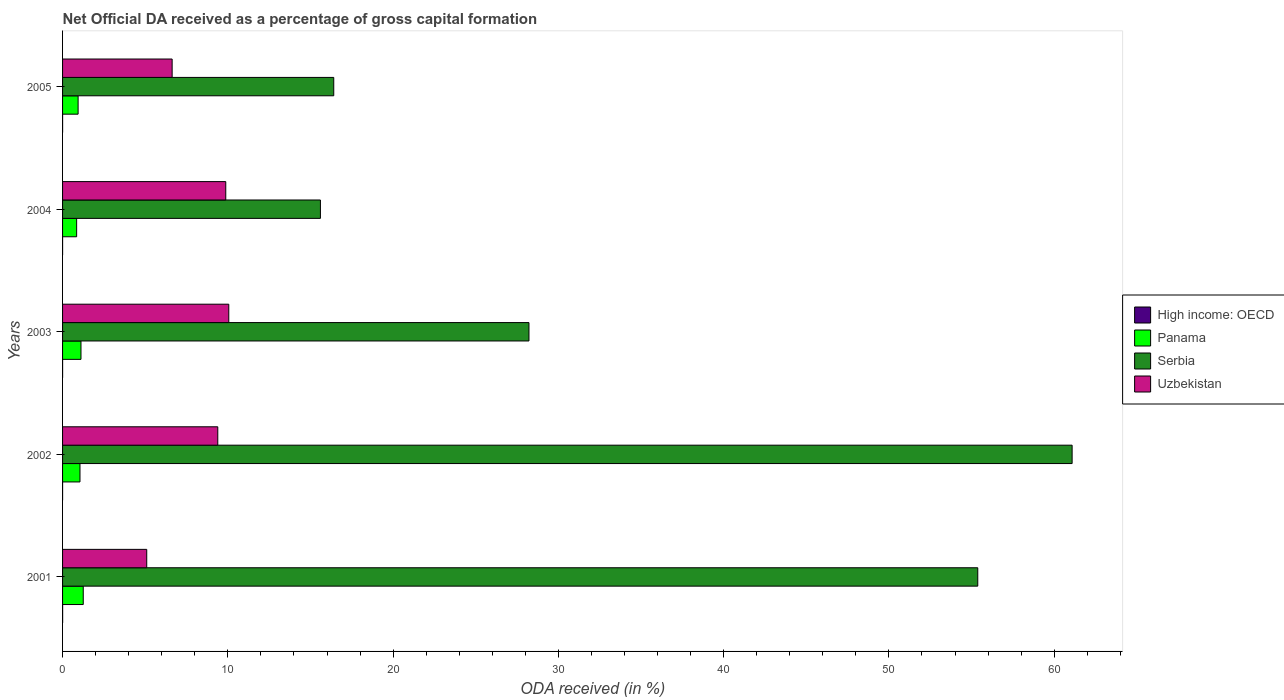How many different coloured bars are there?
Ensure brevity in your answer.  4. How many bars are there on the 2nd tick from the bottom?
Keep it short and to the point. 4. What is the net ODA received in Uzbekistan in 2001?
Provide a short and direct response. 5.09. Across all years, what is the maximum net ODA received in Serbia?
Provide a short and direct response. 61.08. Across all years, what is the minimum net ODA received in Uzbekistan?
Provide a succinct answer. 5.09. In which year was the net ODA received in Panama maximum?
Offer a terse response. 2001. What is the total net ODA received in Serbia in the graph?
Ensure brevity in your answer.  176.69. What is the difference between the net ODA received in Uzbekistan in 2004 and that in 2005?
Give a very brief answer. 3.24. What is the difference between the net ODA received in Serbia in 2001 and the net ODA received in Uzbekistan in 2002?
Provide a succinct answer. 45.98. What is the average net ODA received in High income: OECD per year?
Your response must be concise. 0. In the year 2001, what is the difference between the net ODA received in Uzbekistan and net ODA received in Panama?
Your answer should be very brief. 3.84. What is the ratio of the net ODA received in Uzbekistan in 2003 to that in 2005?
Keep it short and to the point. 1.52. Is the difference between the net ODA received in Uzbekistan in 2002 and 2003 greater than the difference between the net ODA received in Panama in 2002 and 2003?
Your answer should be very brief. No. What is the difference between the highest and the second highest net ODA received in Serbia?
Make the answer very short. 5.71. What is the difference between the highest and the lowest net ODA received in High income: OECD?
Offer a terse response. 0. What does the 4th bar from the top in 2001 represents?
Your answer should be compact. High income: OECD. What does the 1st bar from the bottom in 2001 represents?
Provide a succinct answer. High income: OECD. Are all the bars in the graph horizontal?
Your answer should be compact. Yes. Are the values on the major ticks of X-axis written in scientific E-notation?
Give a very brief answer. No. Does the graph contain any zero values?
Keep it short and to the point. No. How many legend labels are there?
Ensure brevity in your answer.  4. What is the title of the graph?
Ensure brevity in your answer.  Net Official DA received as a percentage of gross capital formation. Does "Vietnam" appear as one of the legend labels in the graph?
Ensure brevity in your answer.  No. What is the label or title of the X-axis?
Offer a terse response. ODA received (in %). What is the label or title of the Y-axis?
Your answer should be very brief. Years. What is the ODA received (in %) of High income: OECD in 2001?
Provide a succinct answer. 0. What is the ODA received (in %) of Panama in 2001?
Ensure brevity in your answer.  1.25. What is the ODA received (in %) in Serbia in 2001?
Your answer should be very brief. 55.38. What is the ODA received (in %) in Uzbekistan in 2001?
Offer a very short reply. 5.09. What is the ODA received (in %) in High income: OECD in 2002?
Provide a succinct answer. 0. What is the ODA received (in %) of Panama in 2002?
Your response must be concise. 1.05. What is the ODA received (in %) in Serbia in 2002?
Provide a short and direct response. 61.08. What is the ODA received (in %) of Uzbekistan in 2002?
Your response must be concise. 9.39. What is the ODA received (in %) in High income: OECD in 2003?
Your answer should be compact. 0. What is the ODA received (in %) of Panama in 2003?
Your response must be concise. 1.11. What is the ODA received (in %) of Serbia in 2003?
Ensure brevity in your answer.  28.22. What is the ODA received (in %) in Uzbekistan in 2003?
Give a very brief answer. 10.06. What is the ODA received (in %) in High income: OECD in 2004?
Your response must be concise. 0. What is the ODA received (in %) in Panama in 2004?
Provide a succinct answer. 0.85. What is the ODA received (in %) in Serbia in 2004?
Offer a terse response. 15.6. What is the ODA received (in %) of Uzbekistan in 2004?
Provide a short and direct response. 9.87. What is the ODA received (in %) of High income: OECD in 2005?
Offer a terse response. 0. What is the ODA received (in %) of Panama in 2005?
Your answer should be very brief. 0.94. What is the ODA received (in %) in Serbia in 2005?
Make the answer very short. 16.41. What is the ODA received (in %) in Uzbekistan in 2005?
Your answer should be compact. 6.63. Across all years, what is the maximum ODA received (in %) in High income: OECD?
Give a very brief answer. 0. Across all years, what is the maximum ODA received (in %) of Panama?
Give a very brief answer. 1.25. Across all years, what is the maximum ODA received (in %) of Serbia?
Provide a succinct answer. 61.08. Across all years, what is the maximum ODA received (in %) in Uzbekistan?
Provide a succinct answer. 10.06. Across all years, what is the minimum ODA received (in %) of High income: OECD?
Give a very brief answer. 0. Across all years, what is the minimum ODA received (in %) of Panama?
Provide a succinct answer. 0.85. Across all years, what is the minimum ODA received (in %) of Serbia?
Your answer should be very brief. 15.6. Across all years, what is the minimum ODA received (in %) of Uzbekistan?
Provide a succinct answer. 5.09. What is the total ODA received (in %) of High income: OECD in the graph?
Offer a very short reply. 0.01. What is the total ODA received (in %) of Panama in the graph?
Make the answer very short. 5.21. What is the total ODA received (in %) in Serbia in the graph?
Keep it short and to the point. 176.69. What is the total ODA received (in %) of Uzbekistan in the graph?
Offer a very short reply. 41.05. What is the difference between the ODA received (in %) of High income: OECD in 2001 and that in 2002?
Offer a terse response. 0. What is the difference between the ODA received (in %) of Panama in 2001 and that in 2002?
Your answer should be very brief. 0.2. What is the difference between the ODA received (in %) in Serbia in 2001 and that in 2002?
Your answer should be compact. -5.71. What is the difference between the ODA received (in %) of Uzbekistan in 2001 and that in 2002?
Ensure brevity in your answer.  -4.3. What is the difference between the ODA received (in %) in High income: OECD in 2001 and that in 2003?
Provide a succinct answer. 0. What is the difference between the ODA received (in %) of Panama in 2001 and that in 2003?
Make the answer very short. 0.14. What is the difference between the ODA received (in %) in Serbia in 2001 and that in 2003?
Provide a short and direct response. 27.16. What is the difference between the ODA received (in %) of Uzbekistan in 2001 and that in 2003?
Offer a terse response. -4.96. What is the difference between the ODA received (in %) of High income: OECD in 2001 and that in 2004?
Offer a terse response. 0. What is the difference between the ODA received (in %) in Panama in 2001 and that in 2004?
Your answer should be very brief. 0.4. What is the difference between the ODA received (in %) of Serbia in 2001 and that in 2004?
Offer a terse response. 39.77. What is the difference between the ODA received (in %) in Uzbekistan in 2001 and that in 2004?
Offer a terse response. -4.78. What is the difference between the ODA received (in %) of High income: OECD in 2001 and that in 2005?
Ensure brevity in your answer.  0. What is the difference between the ODA received (in %) of Panama in 2001 and that in 2005?
Your answer should be compact. 0.31. What is the difference between the ODA received (in %) in Serbia in 2001 and that in 2005?
Provide a succinct answer. 38.97. What is the difference between the ODA received (in %) of Uzbekistan in 2001 and that in 2005?
Your answer should be compact. -1.54. What is the difference between the ODA received (in %) of High income: OECD in 2002 and that in 2003?
Offer a terse response. -0. What is the difference between the ODA received (in %) of Panama in 2002 and that in 2003?
Offer a terse response. -0.06. What is the difference between the ODA received (in %) of Serbia in 2002 and that in 2003?
Ensure brevity in your answer.  32.86. What is the difference between the ODA received (in %) in Uzbekistan in 2002 and that in 2003?
Offer a very short reply. -0.67. What is the difference between the ODA received (in %) in High income: OECD in 2002 and that in 2004?
Your answer should be very brief. 0. What is the difference between the ODA received (in %) of Panama in 2002 and that in 2004?
Offer a terse response. 0.2. What is the difference between the ODA received (in %) of Serbia in 2002 and that in 2004?
Make the answer very short. 45.48. What is the difference between the ODA received (in %) in Uzbekistan in 2002 and that in 2004?
Ensure brevity in your answer.  -0.48. What is the difference between the ODA received (in %) of High income: OECD in 2002 and that in 2005?
Provide a succinct answer. -0. What is the difference between the ODA received (in %) in Panama in 2002 and that in 2005?
Provide a succinct answer. 0.11. What is the difference between the ODA received (in %) of Serbia in 2002 and that in 2005?
Your answer should be very brief. 44.68. What is the difference between the ODA received (in %) of Uzbekistan in 2002 and that in 2005?
Offer a very short reply. 2.76. What is the difference between the ODA received (in %) in High income: OECD in 2003 and that in 2004?
Give a very brief answer. 0. What is the difference between the ODA received (in %) in Panama in 2003 and that in 2004?
Give a very brief answer. 0.26. What is the difference between the ODA received (in %) of Serbia in 2003 and that in 2004?
Provide a succinct answer. 12.62. What is the difference between the ODA received (in %) of Uzbekistan in 2003 and that in 2004?
Ensure brevity in your answer.  0.18. What is the difference between the ODA received (in %) of High income: OECD in 2003 and that in 2005?
Offer a terse response. -0. What is the difference between the ODA received (in %) of Panama in 2003 and that in 2005?
Give a very brief answer. 0.17. What is the difference between the ODA received (in %) of Serbia in 2003 and that in 2005?
Give a very brief answer. 11.81. What is the difference between the ODA received (in %) in Uzbekistan in 2003 and that in 2005?
Provide a short and direct response. 3.43. What is the difference between the ODA received (in %) in High income: OECD in 2004 and that in 2005?
Ensure brevity in your answer.  -0. What is the difference between the ODA received (in %) of Panama in 2004 and that in 2005?
Ensure brevity in your answer.  -0.09. What is the difference between the ODA received (in %) in Serbia in 2004 and that in 2005?
Offer a very short reply. -0.81. What is the difference between the ODA received (in %) of Uzbekistan in 2004 and that in 2005?
Provide a succinct answer. 3.24. What is the difference between the ODA received (in %) of High income: OECD in 2001 and the ODA received (in %) of Panama in 2002?
Your answer should be very brief. -1.05. What is the difference between the ODA received (in %) in High income: OECD in 2001 and the ODA received (in %) in Serbia in 2002?
Offer a terse response. -61.08. What is the difference between the ODA received (in %) of High income: OECD in 2001 and the ODA received (in %) of Uzbekistan in 2002?
Give a very brief answer. -9.39. What is the difference between the ODA received (in %) in Panama in 2001 and the ODA received (in %) in Serbia in 2002?
Provide a succinct answer. -59.83. What is the difference between the ODA received (in %) in Panama in 2001 and the ODA received (in %) in Uzbekistan in 2002?
Offer a very short reply. -8.14. What is the difference between the ODA received (in %) of Serbia in 2001 and the ODA received (in %) of Uzbekistan in 2002?
Ensure brevity in your answer.  45.98. What is the difference between the ODA received (in %) in High income: OECD in 2001 and the ODA received (in %) in Panama in 2003?
Provide a succinct answer. -1.11. What is the difference between the ODA received (in %) in High income: OECD in 2001 and the ODA received (in %) in Serbia in 2003?
Offer a very short reply. -28.22. What is the difference between the ODA received (in %) of High income: OECD in 2001 and the ODA received (in %) of Uzbekistan in 2003?
Keep it short and to the point. -10.05. What is the difference between the ODA received (in %) of Panama in 2001 and the ODA received (in %) of Serbia in 2003?
Ensure brevity in your answer.  -26.97. What is the difference between the ODA received (in %) of Panama in 2001 and the ODA received (in %) of Uzbekistan in 2003?
Your answer should be compact. -8.81. What is the difference between the ODA received (in %) of Serbia in 2001 and the ODA received (in %) of Uzbekistan in 2003?
Your answer should be very brief. 45.32. What is the difference between the ODA received (in %) in High income: OECD in 2001 and the ODA received (in %) in Panama in 2004?
Offer a terse response. -0.85. What is the difference between the ODA received (in %) of High income: OECD in 2001 and the ODA received (in %) of Serbia in 2004?
Provide a succinct answer. -15.6. What is the difference between the ODA received (in %) of High income: OECD in 2001 and the ODA received (in %) of Uzbekistan in 2004?
Make the answer very short. -9.87. What is the difference between the ODA received (in %) of Panama in 2001 and the ODA received (in %) of Serbia in 2004?
Offer a terse response. -14.35. What is the difference between the ODA received (in %) of Panama in 2001 and the ODA received (in %) of Uzbekistan in 2004?
Offer a very short reply. -8.62. What is the difference between the ODA received (in %) in Serbia in 2001 and the ODA received (in %) in Uzbekistan in 2004?
Your answer should be very brief. 45.5. What is the difference between the ODA received (in %) of High income: OECD in 2001 and the ODA received (in %) of Panama in 2005?
Ensure brevity in your answer.  -0.94. What is the difference between the ODA received (in %) in High income: OECD in 2001 and the ODA received (in %) in Serbia in 2005?
Your response must be concise. -16.4. What is the difference between the ODA received (in %) in High income: OECD in 2001 and the ODA received (in %) in Uzbekistan in 2005?
Your answer should be very brief. -6.63. What is the difference between the ODA received (in %) in Panama in 2001 and the ODA received (in %) in Serbia in 2005?
Keep it short and to the point. -15.16. What is the difference between the ODA received (in %) of Panama in 2001 and the ODA received (in %) of Uzbekistan in 2005?
Your response must be concise. -5.38. What is the difference between the ODA received (in %) of Serbia in 2001 and the ODA received (in %) of Uzbekistan in 2005?
Make the answer very short. 48.75. What is the difference between the ODA received (in %) in High income: OECD in 2002 and the ODA received (in %) in Panama in 2003?
Make the answer very short. -1.11. What is the difference between the ODA received (in %) in High income: OECD in 2002 and the ODA received (in %) in Serbia in 2003?
Your answer should be very brief. -28.22. What is the difference between the ODA received (in %) in High income: OECD in 2002 and the ODA received (in %) in Uzbekistan in 2003?
Your answer should be compact. -10.06. What is the difference between the ODA received (in %) in Panama in 2002 and the ODA received (in %) in Serbia in 2003?
Your answer should be very brief. -27.17. What is the difference between the ODA received (in %) of Panama in 2002 and the ODA received (in %) of Uzbekistan in 2003?
Give a very brief answer. -9. What is the difference between the ODA received (in %) in Serbia in 2002 and the ODA received (in %) in Uzbekistan in 2003?
Offer a very short reply. 51.03. What is the difference between the ODA received (in %) of High income: OECD in 2002 and the ODA received (in %) of Panama in 2004?
Your answer should be compact. -0.85. What is the difference between the ODA received (in %) of High income: OECD in 2002 and the ODA received (in %) of Serbia in 2004?
Your answer should be compact. -15.6. What is the difference between the ODA received (in %) of High income: OECD in 2002 and the ODA received (in %) of Uzbekistan in 2004?
Offer a very short reply. -9.87. What is the difference between the ODA received (in %) of Panama in 2002 and the ODA received (in %) of Serbia in 2004?
Your answer should be very brief. -14.55. What is the difference between the ODA received (in %) of Panama in 2002 and the ODA received (in %) of Uzbekistan in 2004?
Provide a short and direct response. -8.82. What is the difference between the ODA received (in %) of Serbia in 2002 and the ODA received (in %) of Uzbekistan in 2004?
Ensure brevity in your answer.  51.21. What is the difference between the ODA received (in %) of High income: OECD in 2002 and the ODA received (in %) of Panama in 2005?
Offer a very short reply. -0.94. What is the difference between the ODA received (in %) in High income: OECD in 2002 and the ODA received (in %) in Serbia in 2005?
Give a very brief answer. -16.41. What is the difference between the ODA received (in %) of High income: OECD in 2002 and the ODA received (in %) of Uzbekistan in 2005?
Give a very brief answer. -6.63. What is the difference between the ODA received (in %) of Panama in 2002 and the ODA received (in %) of Serbia in 2005?
Make the answer very short. -15.35. What is the difference between the ODA received (in %) of Panama in 2002 and the ODA received (in %) of Uzbekistan in 2005?
Your answer should be compact. -5.58. What is the difference between the ODA received (in %) of Serbia in 2002 and the ODA received (in %) of Uzbekistan in 2005?
Ensure brevity in your answer.  54.45. What is the difference between the ODA received (in %) in High income: OECD in 2003 and the ODA received (in %) in Panama in 2004?
Offer a terse response. -0.85. What is the difference between the ODA received (in %) of High income: OECD in 2003 and the ODA received (in %) of Serbia in 2004?
Provide a short and direct response. -15.6. What is the difference between the ODA received (in %) in High income: OECD in 2003 and the ODA received (in %) in Uzbekistan in 2004?
Your answer should be compact. -9.87. What is the difference between the ODA received (in %) of Panama in 2003 and the ODA received (in %) of Serbia in 2004?
Your answer should be very brief. -14.49. What is the difference between the ODA received (in %) of Panama in 2003 and the ODA received (in %) of Uzbekistan in 2004?
Give a very brief answer. -8.76. What is the difference between the ODA received (in %) in Serbia in 2003 and the ODA received (in %) in Uzbekistan in 2004?
Your answer should be compact. 18.35. What is the difference between the ODA received (in %) in High income: OECD in 2003 and the ODA received (in %) in Panama in 2005?
Your answer should be very brief. -0.94. What is the difference between the ODA received (in %) in High income: OECD in 2003 and the ODA received (in %) in Serbia in 2005?
Provide a succinct answer. -16.41. What is the difference between the ODA received (in %) of High income: OECD in 2003 and the ODA received (in %) of Uzbekistan in 2005?
Your answer should be very brief. -6.63. What is the difference between the ODA received (in %) of Panama in 2003 and the ODA received (in %) of Serbia in 2005?
Provide a succinct answer. -15.29. What is the difference between the ODA received (in %) of Panama in 2003 and the ODA received (in %) of Uzbekistan in 2005?
Keep it short and to the point. -5.52. What is the difference between the ODA received (in %) of Serbia in 2003 and the ODA received (in %) of Uzbekistan in 2005?
Ensure brevity in your answer.  21.59. What is the difference between the ODA received (in %) of High income: OECD in 2004 and the ODA received (in %) of Panama in 2005?
Offer a terse response. -0.94. What is the difference between the ODA received (in %) in High income: OECD in 2004 and the ODA received (in %) in Serbia in 2005?
Your answer should be compact. -16.41. What is the difference between the ODA received (in %) in High income: OECD in 2004 and the ODA received (in %) in Uzbekistan in 2005?
Your answer should be very brief. -6.63. What is the difference between the ODA received (in %) in Panama in 2004 and the ODA received (in %) in Serbia in 2005?
Provide a short and direct response. -15.56. What is the difference between the ODA received (in %) of Panama in 2004 and the ODA received (in %) of Uzbekistan in 2005?
Provide a succinct answer. -5.78. What is the difference between the ODA received (in %) of Serbia in 2004 and the ODA received (in %) of Uzbekistan in 2005?
Keep it short and to the point. 8.97. What is the average ODA received (in %) in High income: OECD per year?
Keep it short and to the point. 0. What is the average ODA received (in %) in Panama per year?
Offer a very short reply. 1.04. What is the average ODA received (in %) in Serbia per year?
Your answer should be compact. 35.34. What is the average ODA received (in %) in Uzbekistan per year?
Keep it short and to the point. 8.21. In the year 2001, what is the difference between the ODA received (in %) of High income: OECD and ODA received (in %) of Panama?
Provide a short and direct response. -1.25. In the year 2001, what is the difference between the ODA received (in %) in High income: OECD and ODA received (in %) in Serbia?
Your answer should be compact. -55.37. In the year 2001, what is the difference between the ODA received (in %) of High income: OECD and ODA received (in %) of Uzbekistan?
Your answer should be compact. -5.09. In the year 2001, what is the difference between the ODA received (in %) in Panama and ODA received (in %) in Serbia?
Your answer should be very brief. -54.12. In the year 2001, what is the difference between the ODA received (in %) in Panama and ODA received (in %) in Uzbekistan?
Provide a short and direct response. -3.84. In the year 2001, what is the difference between the ODA received (in %) of Serbia and ODA received (in %) of Uzbekistan?
Keep it short and to the point. 50.28. In the year 2002, what is the difference between the ODA received (in %) of High income: OECD and ODA received (in %) of Panama?
Provide a succinct answer. -1.05. In the year 2002, what is the difference between the ODA received (in %) in High income: OECD and ODA received (in %) in Serbia?
Ensure brevity in your answer.  -61.08. In the year 2002, what is the difference between the ODA received (in %) in High income: OECD and ODA received (in %) in Uzbekistan?
Provide a short and direct response. -9.39. In the year 2002, what is the difference between the ODA received (in %) of Panama and ODA received (in %) of Serbia?
Offer a terse response. -60.03. In the year 2002, what is the difference between the ODA received (in %) of Panama and ODA received (in %) of Uzbekistan?
Ensure brevity in your answer.  -8.34. In the year 2002, what is the difference between the ODA received (in %) of Serbia and ODA received (in %) of Uzbekistan?
Offer a very short reply. 51.69. In the year 2003, what is the difference between the ODA received (in %) of High income: OECD and ODA received (in %) of Panama?
Your answer should be compact. -1.11. In the year 2003, what is the difference between the ODA received (in %) of High income: OECD and ODA received (in %) of Serbia?
Your answer should be very brief. -28.22. In the year 2003, what is the difference between the ODA received (in %) of High income: OECD and ODA received (in %) of Uzbekistan?
Provide a succinct answer. -10.06. In the year 2003, what is the difference between the ODA received (in %) in Panama and ODA received (in %) in Serbia?
Keep it short and to the point. -27.11. In the year 2003, what is the difference between the ODA received (in %) in Panama and ODA received (in %) in Uzbekistan?
Give a very brief answer. -8.94. In the year 2003, what is the difference between the ODA received (in %) in Serbia and ODA received (in %) in Uzbekistan?
Your answer should be very brief. 18.16. In the year 2004, what is the difference between the ODA received (in %) in High income: OECD and ODA received (in %) in Panama?
Offer a terse response. -0.85. In the year 2004, what is the difference between the ODA received (in %) of High income: OECD and ODA received (in %) of Serbia?
Your response must be concise. -15.6. In the year 2004, what is the difference between the ODA received (in %) in High income: OECD and ODA received (in %) in Uzbekistan?
Make the answer very short. -9.87. In the year 2004, what is the difference between the ODA received (in %) of Panama and ODA received (in %) of Serbia?
Provide a succinct answer. -14.75. In the year 2004, what is the difference between the ODA received (in %) of Panama and ODA received (in %) of Uzbekistan?
Offer a terse response. -9.02. In the year 2004, what is the difference between the ODA received (in %) of Serbia and ODA received (in %) of Uzbekistan?
Your response must be concise. 5.73. In the year 2005, what is the difference between the ODA received (in %) of High income: OECD and ODA received (in %) of Panama?
Make the answer very short. -0.94. In the year 2005, what is the difference between the ODA received (in %) of High income: OECD and ODA received (in %) of Serbia?
Offer a very short reply. -16.41. In the year 2005, what is the difference between the ODA received (in %) of High income: OECD and ODA received (in %) of Uzbekistan?
Offer a terse response. -6.63. In the year 2005, what is the difference between the ODA received (in %) in Panama and ODA received (in %) in Serbia?
Provide a short and direct response. -15.47. In the year 2005, what is the difference between the ODA received (in %) in Panama and ODA received (in %) in Uzbekistan?
Your response must be concise. -5.69. In the year 2005, what is the difference between the ODA received (in %) in Serbia and ODA received (in %) in Uzbekistan?
Make the answer very short. 9.78. What is the ratio of the ODA received (in %) in High income: OECD in 2001 to that in 2002?
Provide a succinct answer. 4.45. What is the ratio of the ODA received (in %) in Panama in 2001 to that in 2002?
Provide a short and direct response. 1.19. What is the ratio of the ODA received (in %) of Serbia in 2001 to that in 2002?
Give a very brief answer. 0.91. What is the ratio of the ODA received (in %) of Uzbekistan in 2001 to that in 2002?
Provide a short and direct response. 0.54. What is the ratio of the ODA received (in %) in High income: OECD in 2001 to that in 2003?
Your response must be concise. 2.66. What is the ratio of the ODA received (in %) in Panama in 2001 to that in 2003?
Offer a terse response. 1.12. What is the ratio of the ODA received (in %) in Serbia in 2001 to that in 2003?
Ensure brevity in your answer.  1.96. What is the ratio of the ODA received (in %) of Uzbekistan in 2001 to that in 2003?
Offer a terse response. 0.51. What is the ratio of the ODA received (in %) in High income: OECD in 2001 to that in 2004?
Your response must be concise. 4.75. What is the ratio of the ODA received (in %) of Panama in 2001 to that in 2004?
Ensure brevity in your answer.  1.47. What is the ratio of the ODA received (in %) of Serbia in 2001 to that in 2004?
Make the answer very short. 3.55. What is the ratio of the ODA received (in %) in Uzbekistan in 2001 to that in 2004?
Your response must be concise. 0.52. What is the ratio of the ODA received (in %) of High income: OECD in 2001 to that in 2005?
Your answer should be compact. 1.66. What is the ratio of the ODA received (in %) of Panama in 2001 to that in 2005?
Ensure brevity in your answer.  1.33. What is the ratio of the ODA received (in %) in Serbia in 2001 to that in 2005?
Keep it short and to the point. 3.37. What is the ratio of the ODA received (in %) in Uzbekistan in 2001 to that in 2005?
Your response must be concise. 0.77. What is the ratio of the ODA received (in %) of High income: OECD in 2002 to that in 2003?
Offer a terse response. 0.6. What is the ratio of the ODA received (in %) of Panama in 2002 to that in 2003?
Your answer should be compact. 0.95. What is the ratio of the ODA received (in %) of Serbia in 2002 to that in 2003?
Your response must be concise. 2.16. What is the ratio of the ODA received (in %) of Uzbekistan in 2002 to that in 2003?
Provide a short and direct response. 0.93. What is the ratio of the ODA received (in %) of High income: OECD in 2002 to that in 2004?
Give a very brief answer. 1.07. What is the ratio of the ODA received (in %) in Panama in 2002 to that in 2004?
Ensure brevity in your answer.  1.24. What is the ratio of the ODA received (in %) of Serbia in 2002 to that in 2004?
Keep it short and to the point. 3.92. What is the ratio of the ODA received (in %) of Uzbekistan in 2002 to that in 2004?
Your answer should be very brief. 0.95. What is the ratio of the ODA received (in %) of High income: OECD in 2002 to that in 2005?
Offer a terse response. 0.37. What is the ratio of the ODA received (in %) in Panama in 2002 to that in 2005?
Ensure brevity in your answer.  1.12. What is the ratio of the ODA received (in %) in Serbia in 2002 to that in 2005?
Provide a short and direct response. 3.72. What is the ratio of the ODA received (in %) in Uzbekistan in 2002 to that in 2005?
Your answer should be compact. 1.42. What is the ratio of the ODA received (in %) of High income: OECD in 2003 to that in 2004?
Your response must be concise. 1.79. What is the ratio of the ODA received (in %) in Panama in 2003 to that in 2004?
Provide a short and direct response. 1.31. What is the ratio of the ODA received (in %) in Serbia in 2003 to that in 2004?
Provide a succinct answer. 1.81. What is the ratio of the ODA received (in %) in Uzbekistan in 2003 to that in 2004?
Your answer should be compact. 1.02. What is the ratio of the ODA received (in %) in High income: OECD in 2003 to that in 2005?
Your answer should be compact. 0.62. What is the ratio of the ODA received (in %) in Panama in 2003 to that in 2005?
Make the answer very short. 1.19. What is the ratio of the ODA received (in %) of Serbia in 2003 to that in 2005?
Offer a very short reply. 1.72. What is the ratio of the ODA received (in %) of Uzbekistan in 2003 to that in 2005?
Ensure brevity in your answer.  1.52. What is the ratio of the ODA received (in %) of High income: OECD in 2004 to that in 2005?
Your response must be concise. 0.35. What is the ratio of the ODA received (in %) of Panama in 2004 to that in 2005?
Provide a short and direct response. 0.91. What is the ratio of the ODA received (in %) of Serbia in 2004 to that in 2005?
Your answer should be very brief. 0.95. What is the ratio of the ODA received (in %) of Uzbekistan in 2004 to that in 2005?
Your response must be concise. 1.49. What is the difference between the highest and the second highest ODA received (in %) of High income: OECD?
Offer a terse response. 0. What is the difference between the highest and the second highest ODA received (in %) of Panama?
Offer a very short reply. 0.14. What is the difference between the highest and the second highest ODA received (in %) in Serbia?
Your answer should be very brief. 5.71. What is the difference between the highest and the second highest ODA received (in %) of Uzbekistan?
Offer a very short reply. 0.18. What is the difference between the highest and the lowest ODA received (in %) in High income: OECD?
Offer a very short reply. 0. What is the difference between the highest and the lowest ODA received (in %) of Panama?
Your answer should be compact. 0.4. What is the difference between the highest and the lowest ODA received (in %) of Serbia?
Offer a very short reply. 45.48. What is the difference between the highest and the lowest ODA received (in %) of Uzbekistan?
Keep it short and to the point. 4.96. 